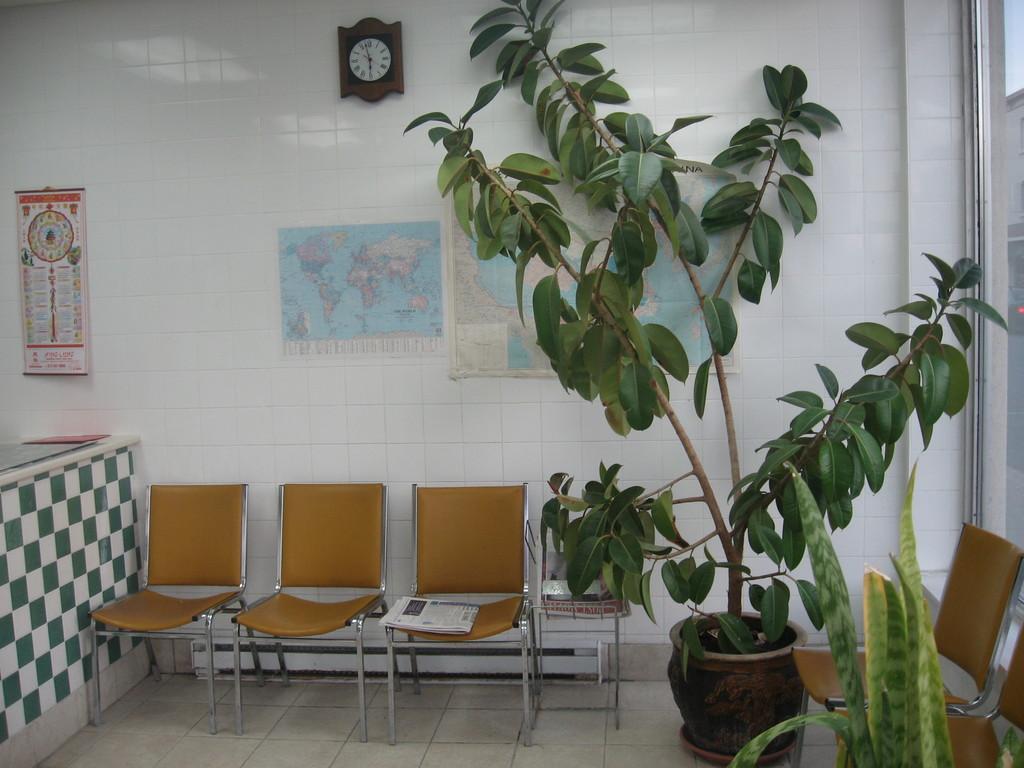Describe this image in one or two sentences. In this image there is a table beside that there are chairs on which we can see there is a news paper, also there is a big plant pot and aloe vera plant, behind the chairs there is a wall on which we can see there is a wall clock, maps and calendar. 